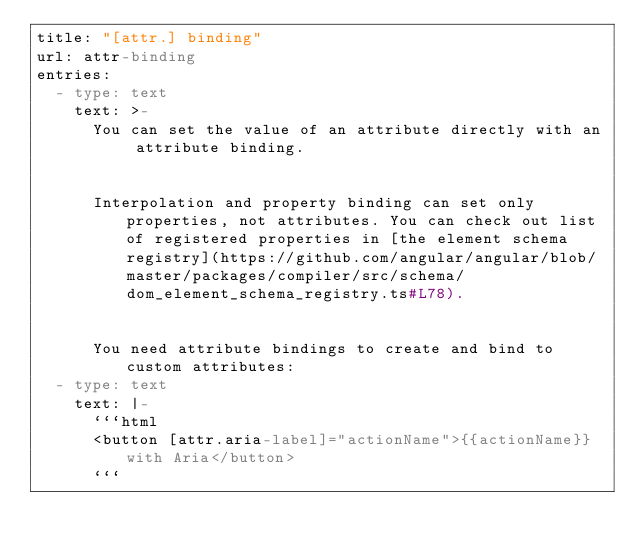Convert code to text. <code><loc_0><loc_0><loc_500><loc_500><_YAML_>title: "[attr.] binding"
url: attr-binding
entries:
  - type: text
    text: >-
      You can set the value of an attribute directly with an attribute binding.


      Interpolation and property binding can set only properties, not attributes. You can check out list of registered properties in [the element schema registry](https://github.com/angular/angular/blob/master/packages/compiler/src/schema/dom_element_schema_registry.ts#L78).


      You need attribute bindings to create and bind to custom attributes:
  - type: text
    text: |-
      ```html
      <button [attr.aria-label]="actionName">{{actionName}} with Aria</button>
      ```
</code> 